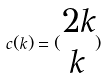<formula> <loc_0><loc_0><loc_500><loc_500>c ( k ) = ( \begin{matrix} 2 k \\ k \end{matrix} )</formula> 